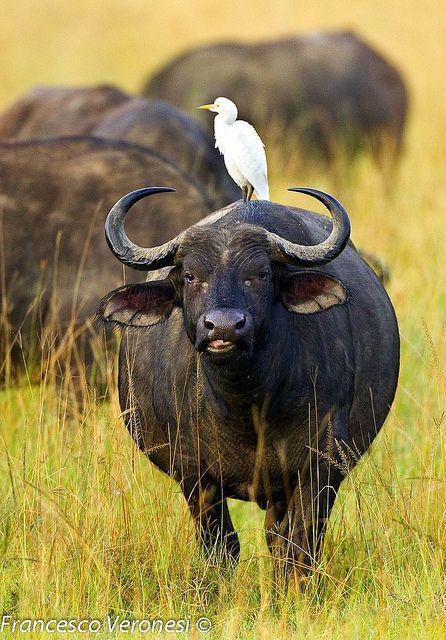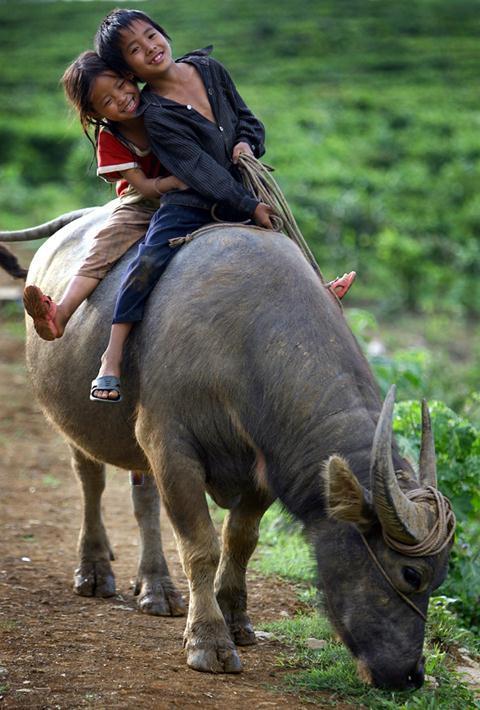The first image is the image on the left, the second image is the image on the right. For the images shown, is this caption "There is at least one person in each image with a water buffalo." true? Answer yes or no. No. 